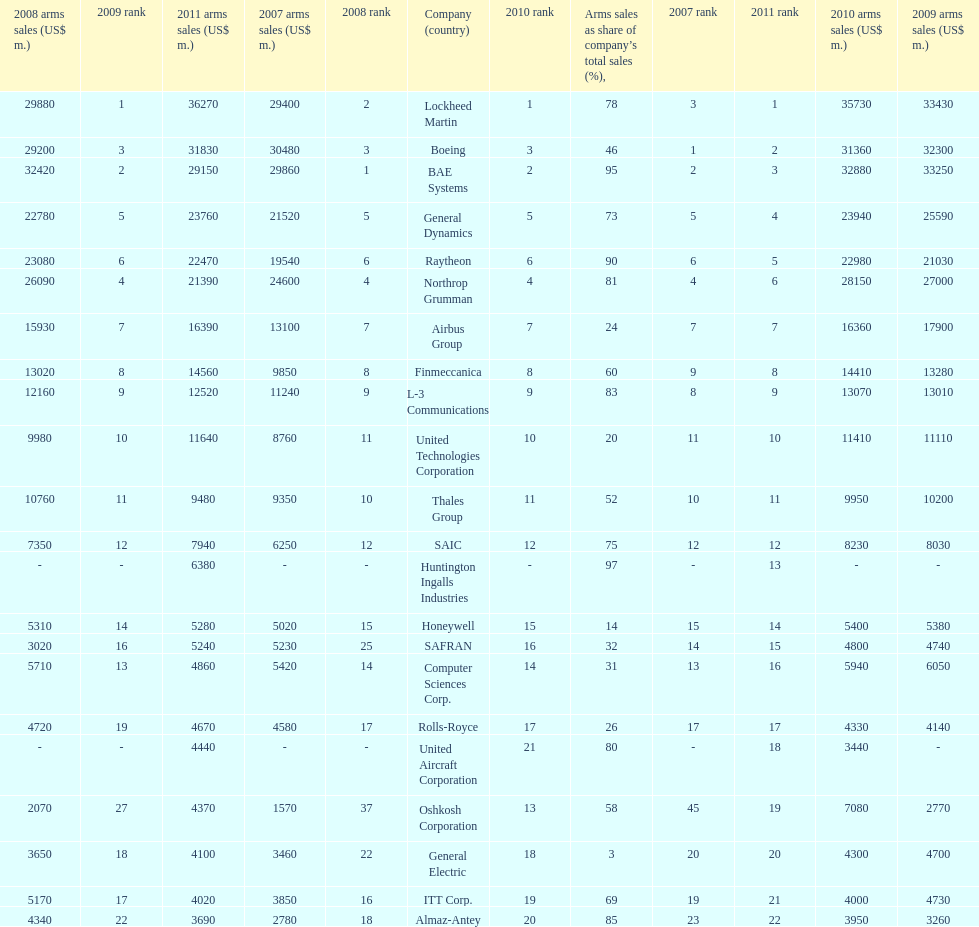How many companies are under the united states? 14. 